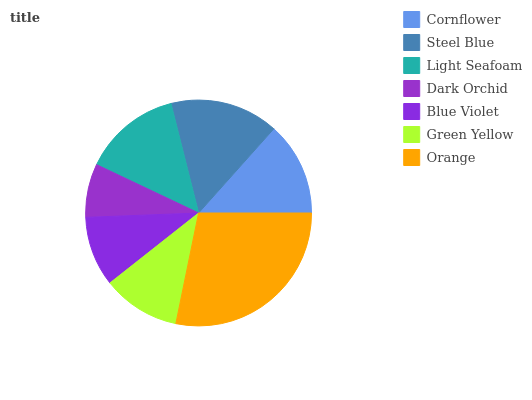Is Dark Orchid the minimum?
Answer yes or no. Yes. Is Orange the maximum?
Answer yes or no. Yes. Is Steel Blue the minimum?
Answer yes or no. No. Is Steel Blue the maximum?
Answer yes or no. No. Is Steel Blue greater than Cornflower?
Answer yes or no. Yes. Is Cornflower less than Steel Blue?
Answer yes or no. Yes. Is Cornflower greater than Steel Blue?
Answer yes or no. No. Is Steel Blue less than Cornflower?
Answer yes or no. No. Is Cornflower the high median?
Answer yes or no. Yes. Is Cornflower the low median?
Answer yes or no. Yes. Is Light Seafoam the high median?
Answer yes or no. No. Is Steel Blue the low median?
Answer yes or no. No. 